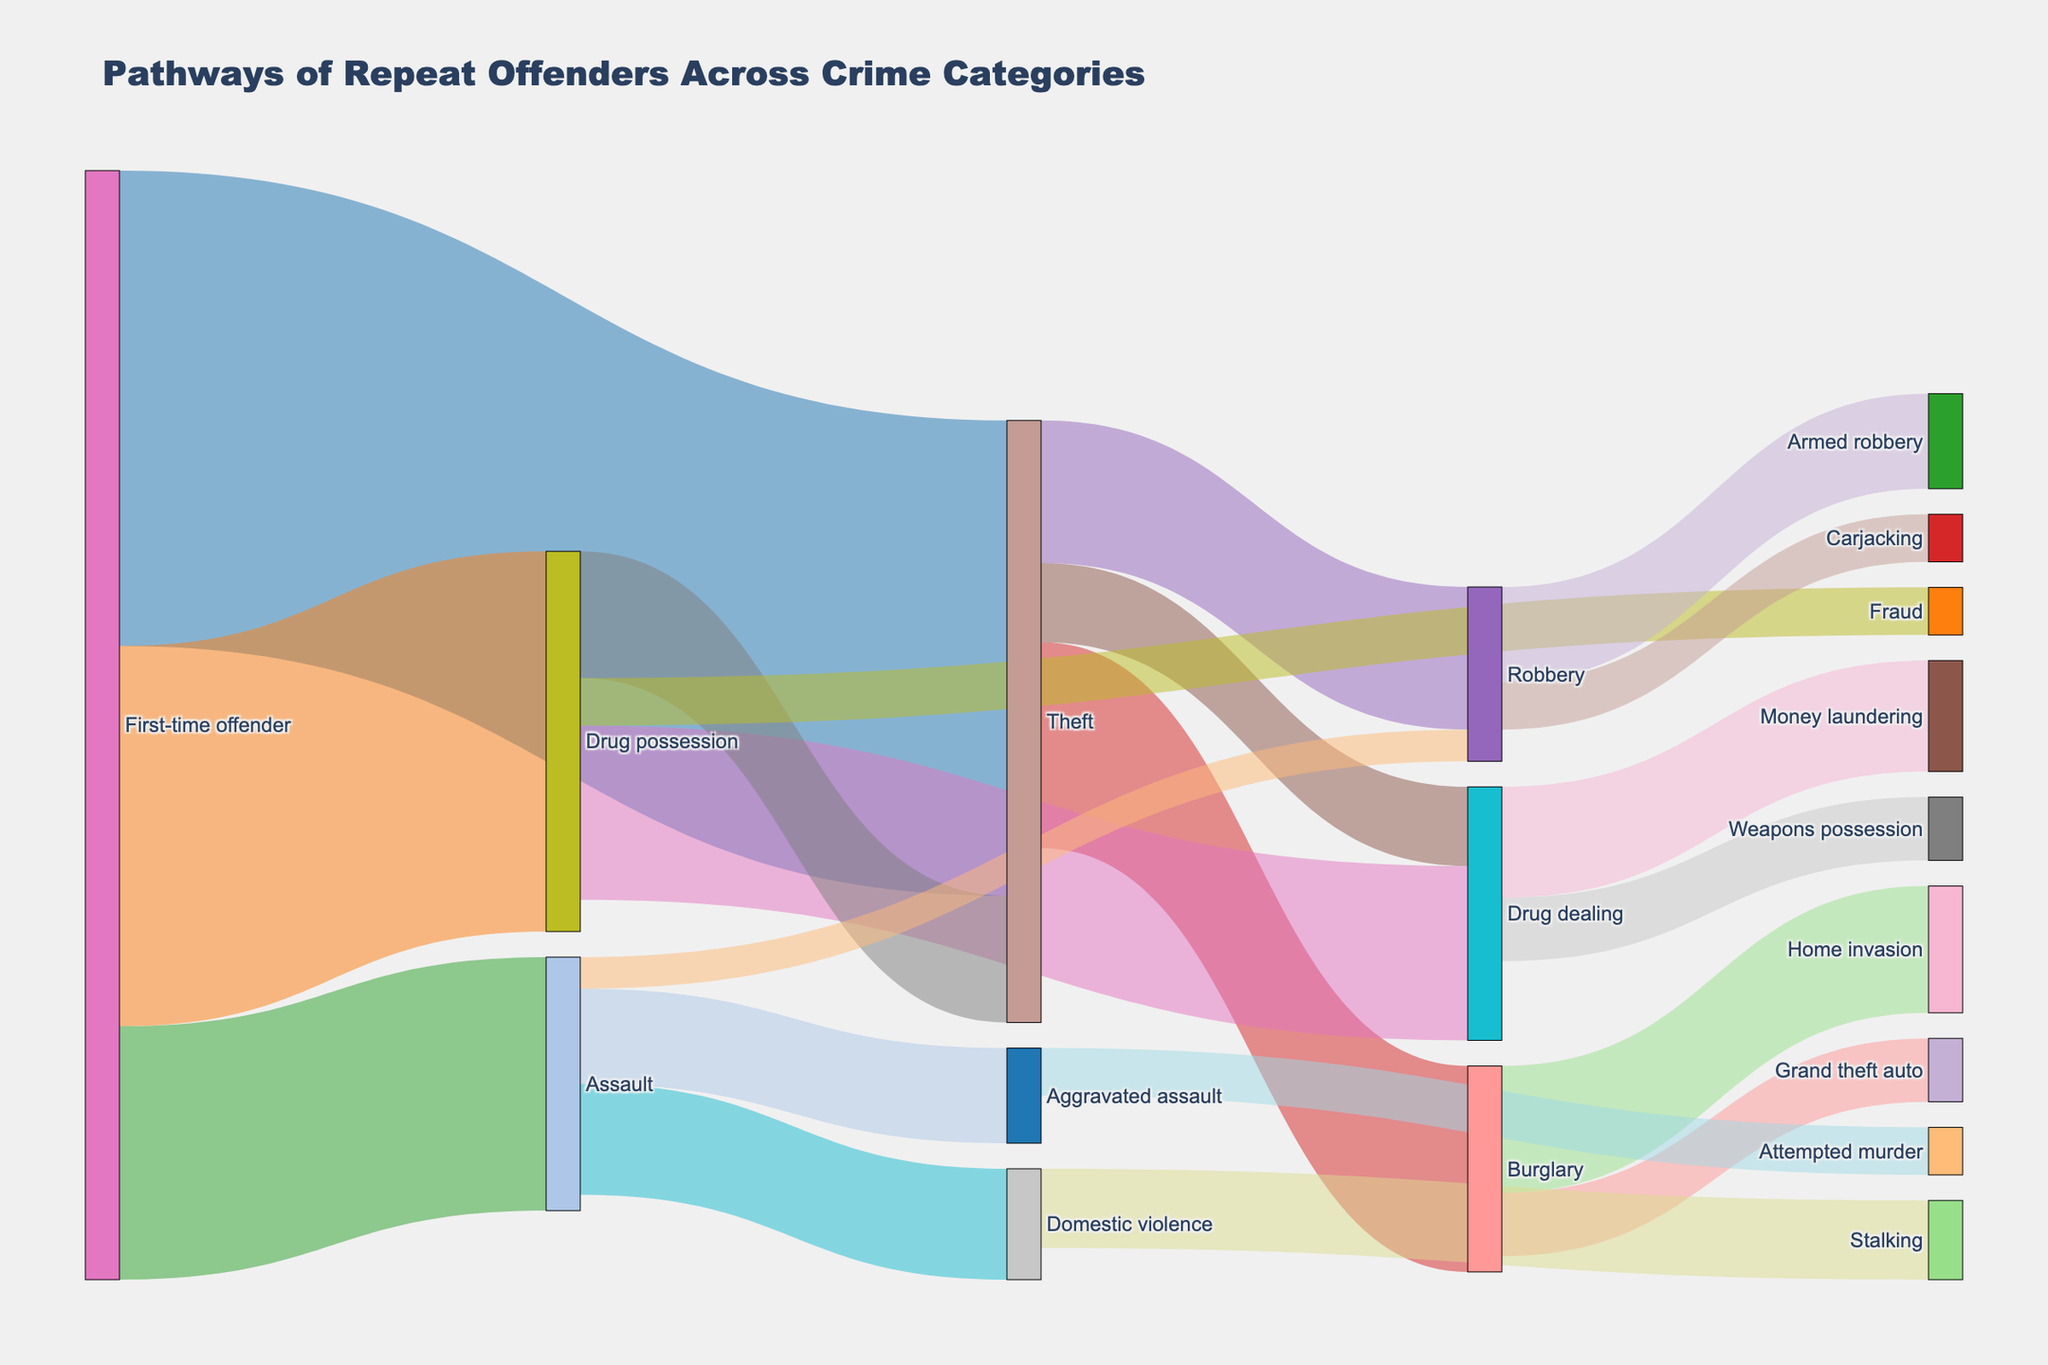What is the most common crime committed by first-time offenders? The Sankey diagram shows that among first-time offenders, the largest flow is to Theft, with a value of 150.
Answer: Theft Which crime do offenders most frequently progress to after committing Theft? According to the diagram, the largest flow from Theft is to Burglary, with a value of 65.
Answer: Burglary How many offenders transition from Drug possession to Fraud? The Sankey chart shows a flow from Drug possession to Fraud, with a value of 15.
Answer: 15 Compare the number of offenders who transition from Assault to Domestic violence and those who transition from Assault to Aggravated assault. Which is higher and by how much? From the figure, Assault to Domestic violence has a value of 35 and Assault to Aggravated assault has a value of 30. The difference is 35 - 30 = 5.
Answer: Domestic violence by 5 What is the total number of offenders who transition from the Theft category to any other crime category? Summing the values from Theft to Burglary (65), Robbery (45), and Drug dealing (25), we get 65 + 45 + 25 = 135.
Answer: 135 Which crime has the fewest offenders transitioning into it directly from a different category? The pathway from Assault to Robbery shows the smallest value, which is 10.
Answer: Robbery Identify the criminal pathway that leads to Money laundering. The figure shows that the pathway leading to Money laundering comes from Drug dealing, with a value of 35.
Answer: Drug dealing Which pathway has a higher number of offenders, Burglary to Home invasion or Burglary to Grand theft auto? The Sankey diagram indicates that Burglary to Home invasion has a value of 40, whereas Burglary to Grand theft auto has a value of 20.
Answer: Burglary to Home invasion Add up all the offenders who transition to any specific crime category from Drug possession. The values are 55 (Drug dealing), 40 (Theft), and 15 (Fraud). Adding these gives 55 + 40 + 15 = 110.
Answer: 110 What proportion of first-time offenders commit Assault? The value for first-time offenders transitioning to Assault is 80, and the total number of first-time offenders is the sum of the transitions to Theft, Drug possession, and Assault (150 + 120 + 80 = 350). Therefore, the proportion is 80 / 350, which is approximately 0.229 or 22.9%.
Answer: 22.9% 